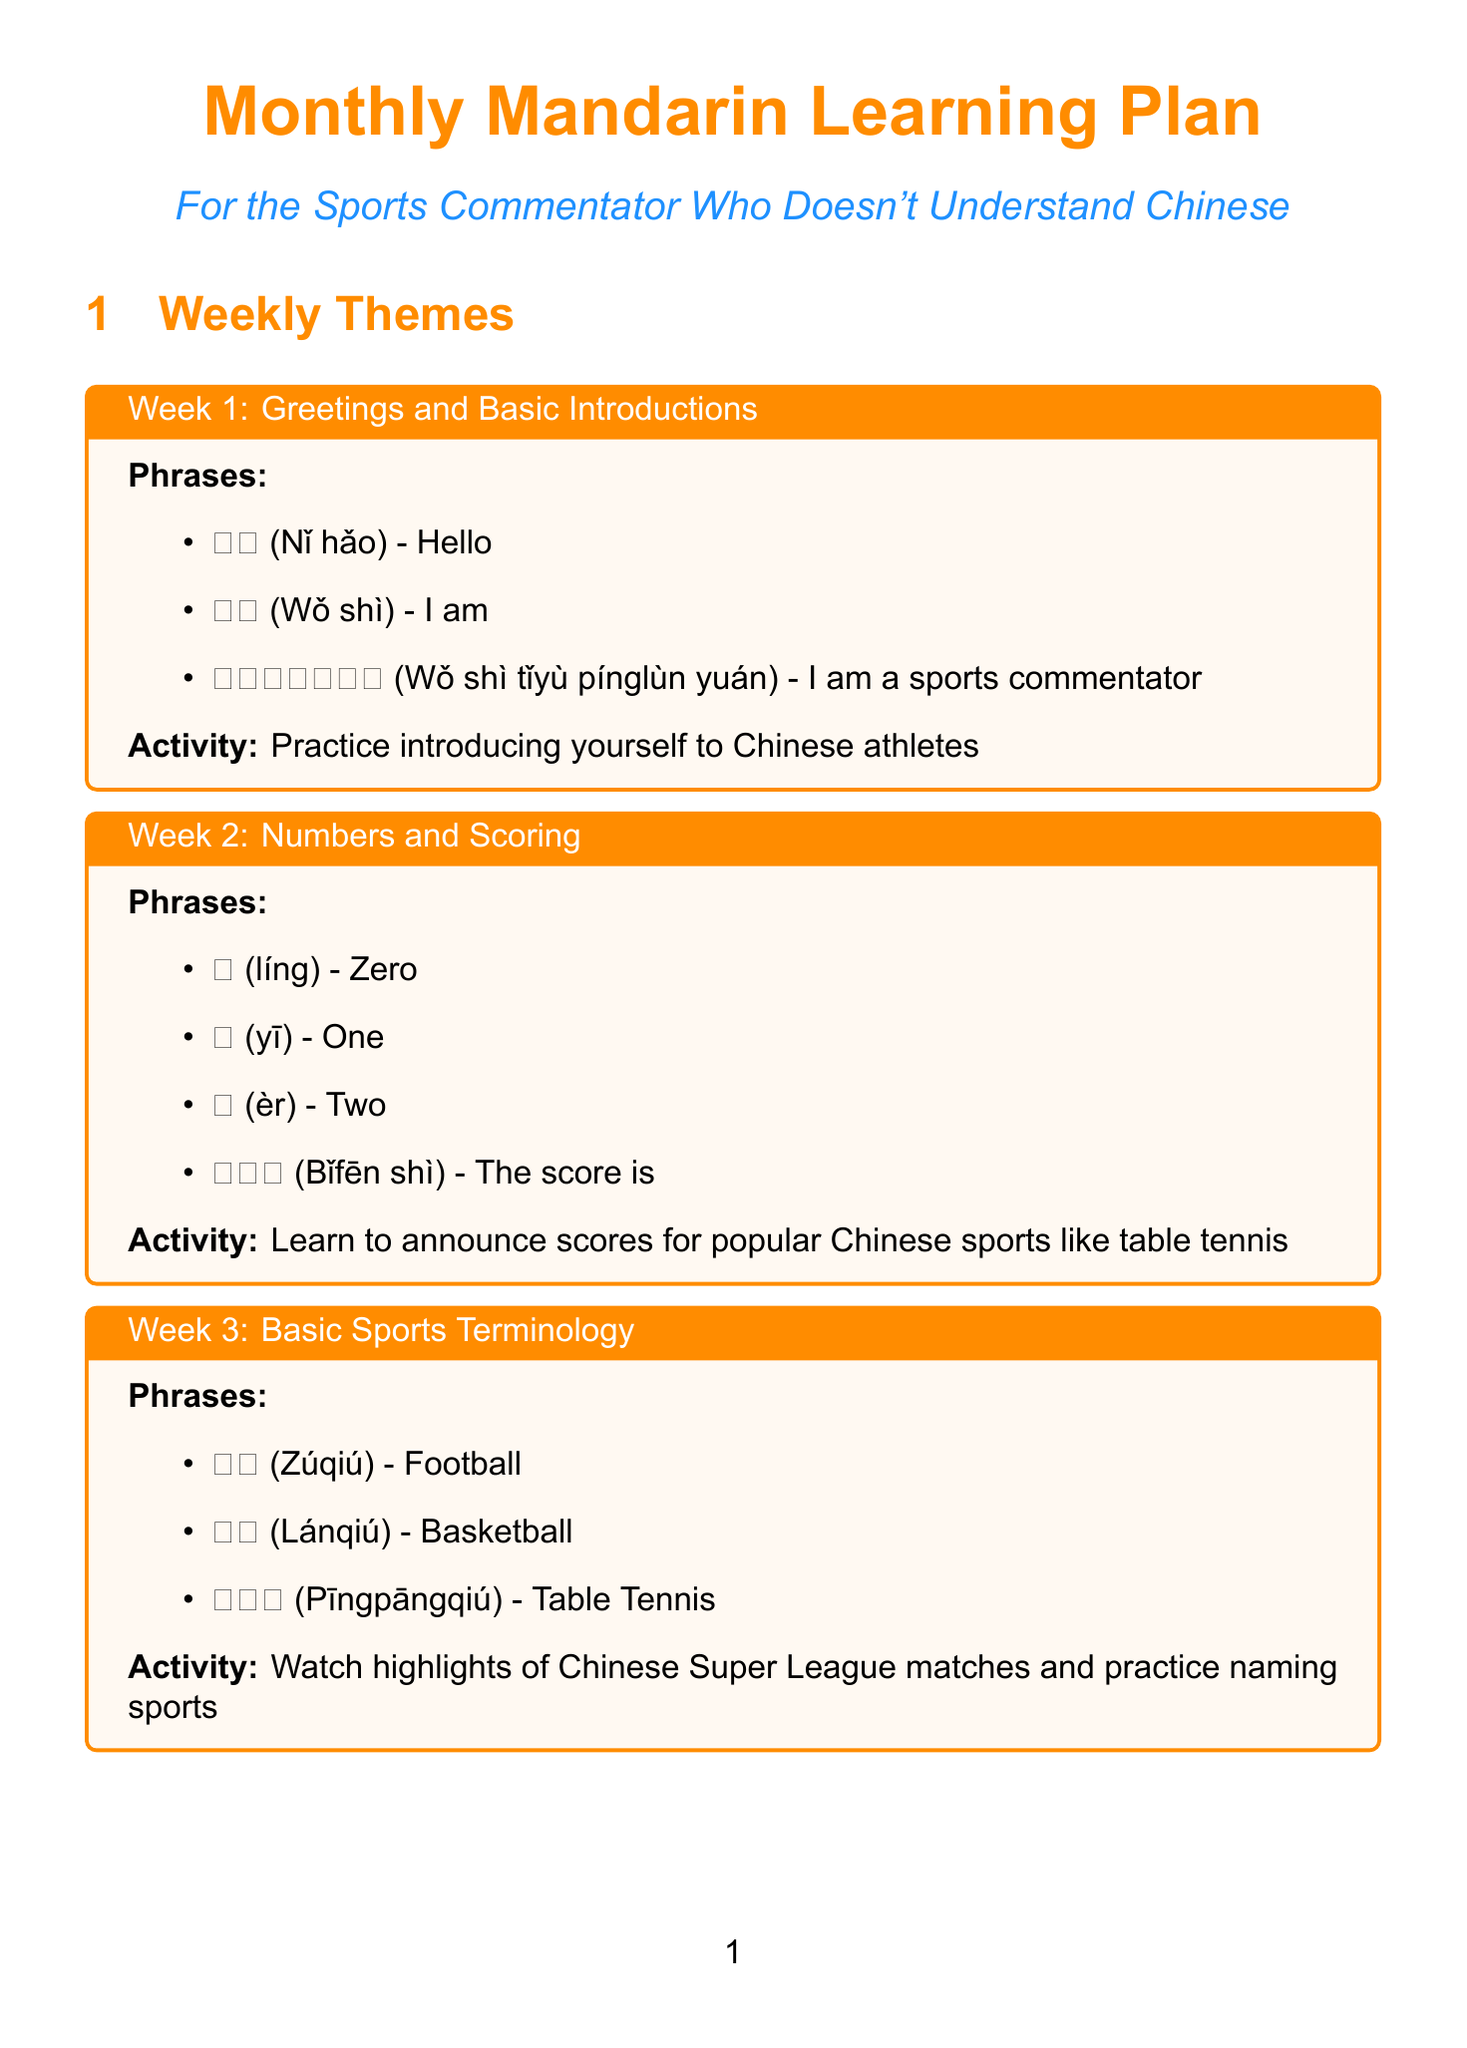what is the theme for week 1? The theme for week 1 is specified in the weekly themes section of the document.
Answer: Greetings and Basic Introductions what is the relevant phrase for the Chinese Grand Prix? This phrase is found in the Important Events section related to the Chinese Grand Prix.
Answer: 一级方程式赛车 (Yījí fāngchéngshì sàichē) how many weeks are in the plan? The number of weeks is indicated by the number of entries in the weekly themes section.
Answer: 4 what is the activity for week 3? The activity for week 3 is detailed in the respective weekly theme box.
Answer: Watch highlights of Chinese Super League matches and practice naming sports what is a cultural note about table tennis? The description of table tennis's cultural significance is provided in the cultural notes section.
Answer: Table tennis is often referred to as the national sport of China what sport is associated with Yao Ming? This information can be found in the popularity of basketball cultural note.
Answer: Basketball which app is suggested for learning Mandarin phrases? The useful resources section lists applications helpful for learning Mandarin.
Answer: HelloChinese App what is the location of the CBA Finals? The location is mentioned in the Important Events section regarding the CBA Finals.
Answer: Various cities in China 